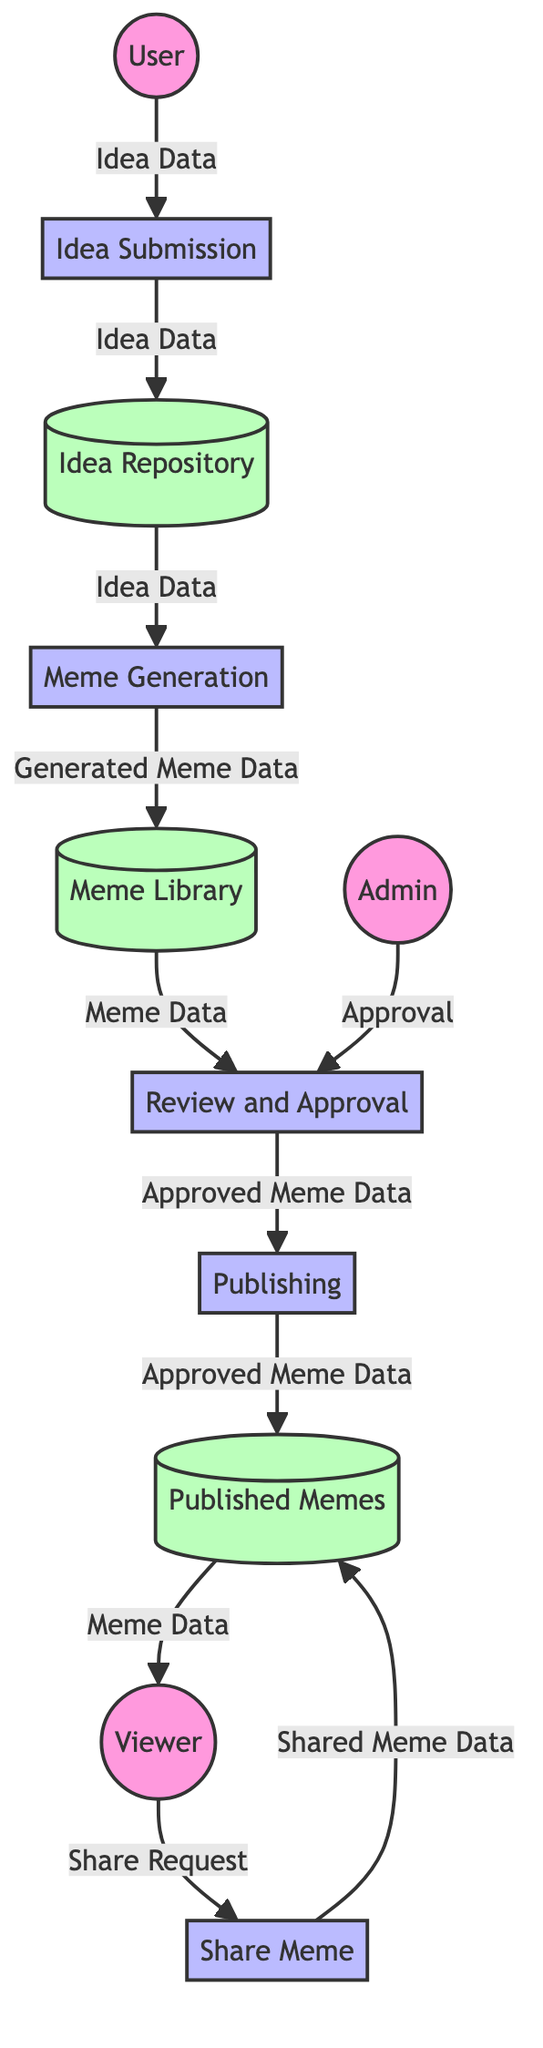What is the first process that the User interacts with? The User starts by submitting a meme idea, which is processed in the "Idea Submission" step.
Answer: Idea Submission How many external entities are in the diagram? The diagram shows three external entities: User, Admin, and Viewer.
Answer: 3 What type of data is stored in the "Idea Repository"? The "Idea Repository" specifically stores all submitted meme ideas from users.
Answer: Submitted meme ideas Which process is responsible for approving memes? The "Review and Approval" process is designated for evaluating and approving memes.
Answer: Review and Approval What data flow occurs after meme generation? After memes are generated, the "Generated Meme Data" flows into the "Meme Library" for storage.
Answer: Generated Meme Data What does the Viewer do with the published memes? The Viewer interacts with the published memes by sharing them on social media platforms.
Answer: Share Which process comes directly after the "Review and Approval"? After memes have been reviewed and approved, the next step is "Publishing," to make them publicly available.
Answer: Publishing How many data stores are present in the diagram? The diagram contains four data stores: Idea Repository, Meme Library, Published Memes, and one more if applicable.
Answer: 4 What is the final step for memes in the data flow? The final step for memes in the workflow is sharing, where viewers distribute memes on social media.
Answer: Share Meme Which external entity acts on approving memes? The Admin is the external entity responsible for the approval of memes.
Answer: Admin 